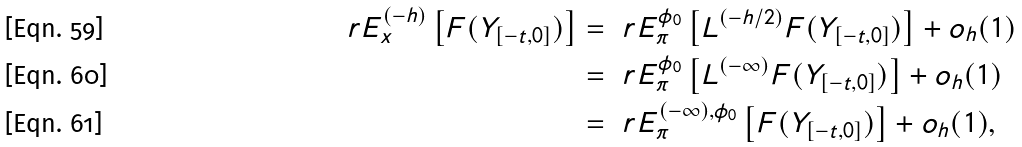<formula> <loc_0><loc_0><loc_500><loc_500>\ r E _ { x } ^ { ( - h ) } \left [ F ( Y _ { [ - t , 0 ] } ) \right ] & = \ r E _ { \pi } ^ { \phi _ { 0 } } \left [ L ^ { ( - h / 2 ) } F ( { Y } _ { [ - t , 0 ] } ) \right ] + o _ { h } ( 1 ) \\ & = \ r E _ { \pi } ^ { \phi _ { 0 } } \left [ L ^ { ( - \infty ) } F ( { Y } _ { [ - t , 0 ] } ) \right ] + o _ { h } ( 1 ) \\ & = \ r E _ { \pi } ^ { ( - \infty ) , \phi _ { 0 } } \left [ F ( { Y } _ { [ - t , 0 ] } ) \right ] + o _ { h } ( 1 ) ,</formula> 